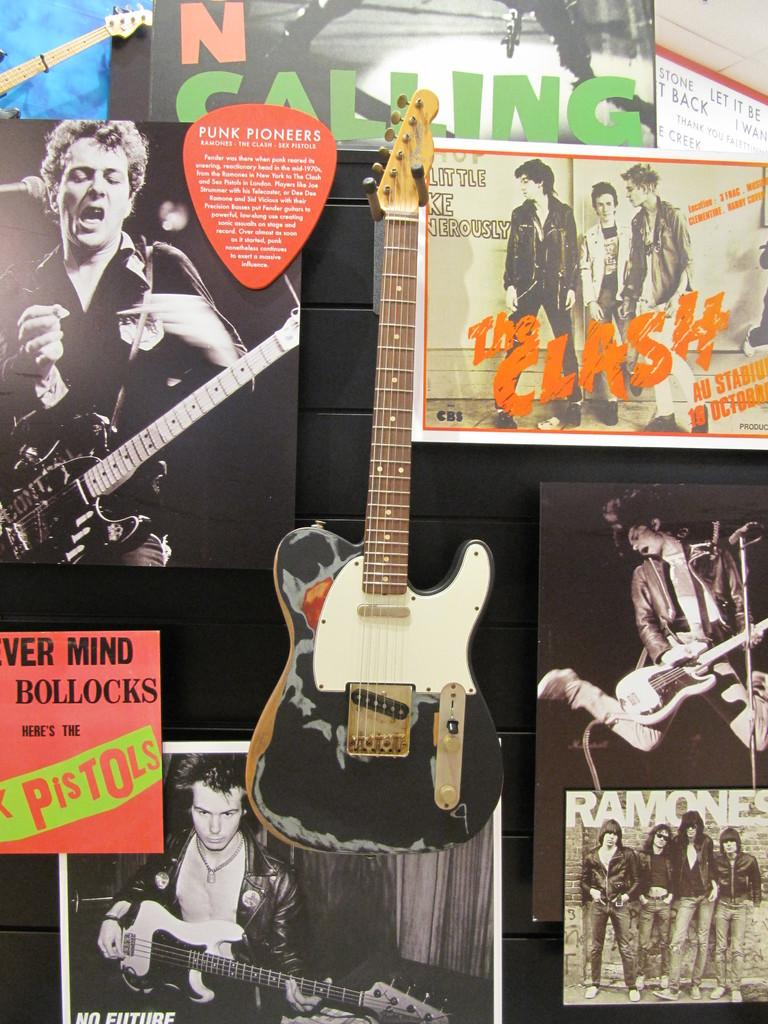What musical instrument is visible in the image? There is a guitar in the image. What can be seen in the background of the image? There are posters in the background of the image. What is depicted on one of the posters? One of the posters depicts a person singing while holding a guitar. How many people are standing in the image? Four persons are standing in the image. What type of eggnog is being served in the image? There is no eggnog present in the image. How many toes can be seen on the persons standing in the image? The number of toes cannot be determined from the image, as it only shows the persons from the waist up. 